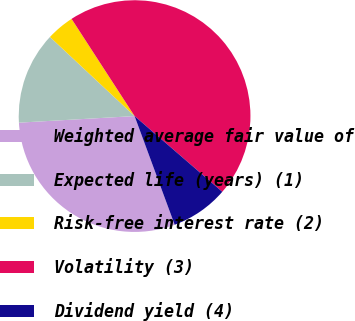Convert chart to OTSL. <chart><loc_0><loc_0><loc_500><loc_500><pie_chart><fcel>Weighted average fair value of<fcel>Expected life (years) (1)<fcel>Risk-free interest rate (2)<fcel>Volatility (3)<fcel>Dividend yield (4)<nl><fcel>29.72%<fcel>12.87%<fcel>3.88%<fcel>45.49%<fcel>8.04%<nl></chart> 